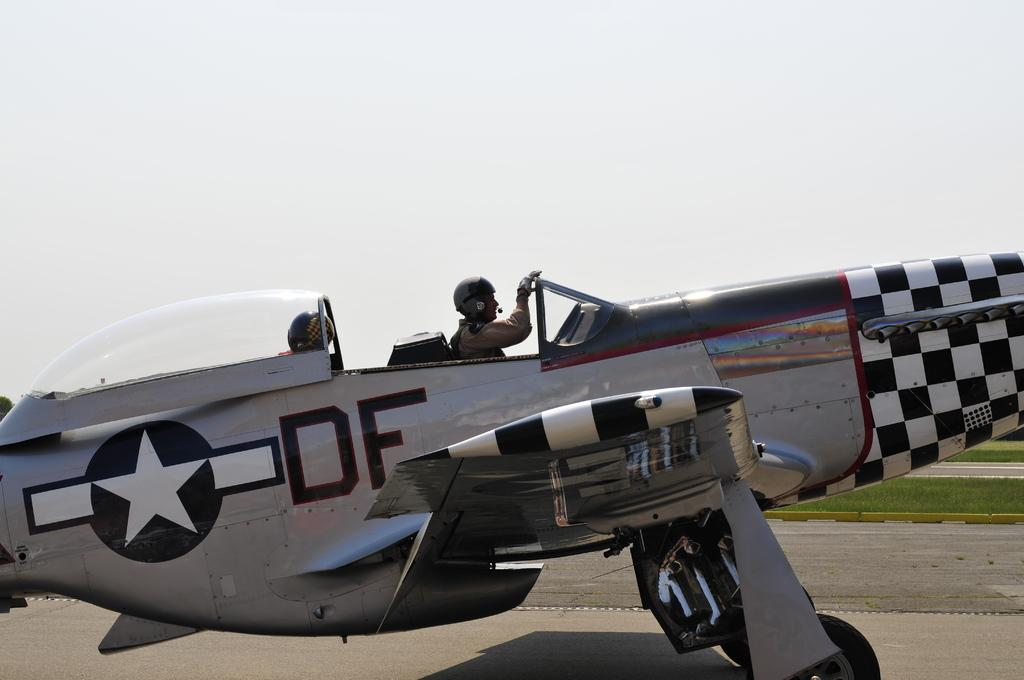<image>
Offer a succinct explanation of the picture presented. A restored open cockpit airplane with a checkered nose has a star and the letters DF painted on the side. 